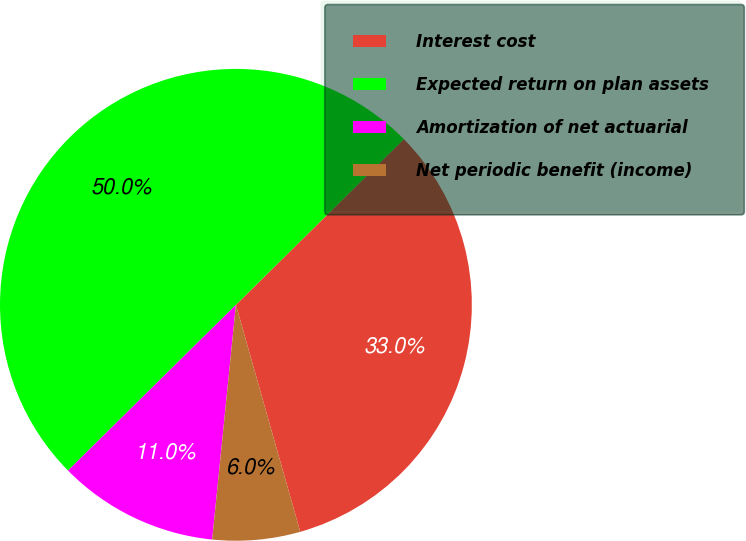<chart> <loc_0><loc_0><loc_500><loc_500><pie_chart><fcel>Interest cost<fcel>Expected return on plan assets<fcel>Amortization of net actuarial<fcel>Net periodic benefit (income)<nl><fcel>33.0%<fcel>50.0%<fcel>11.0%<fcel>6.0%<nl></chart> 